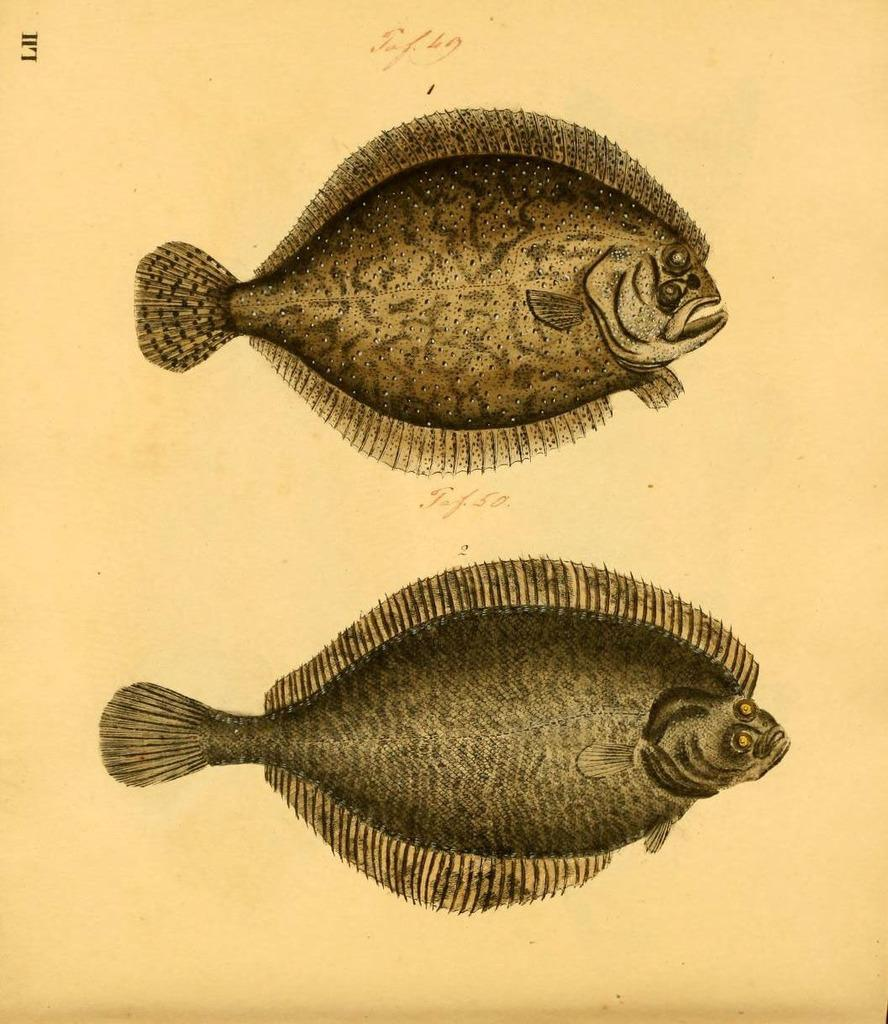What type of drawings can be seen in the image? There are drawings of fishes in the image. Where is the nest of the fishes in the image? There is no nest present in the image, as the drawings depict fishes and not birds or other animals that build nests. 